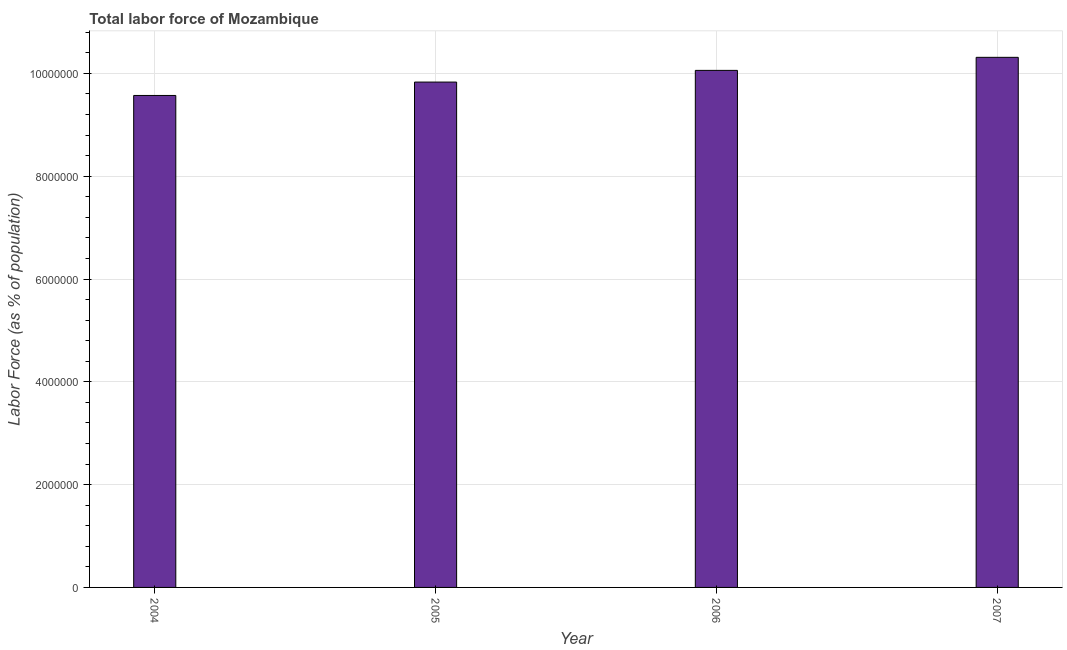What is the title of the graph?
Your answer should be very brief. Total labor force of Mozambique. What is the label or title of the X-axis?
Provide a short and direct response. Year. What is the label or title of the Y-axis?
Your answer should be compact. Labor Force (as % of population). What is the total labor force in 2005?
Ensure brevity in your answer.  9.83e+06. Across all years, what is the maximum total labor force?
Ensure brevity in your answer.  1.03e+07. Across all years, what is the minimum total labor force?
Your answer should be compact. 9.57e+06. In which year was the total labor force maximum?
Provide a succinct answer. 2007. In which year was the total labor force minimum?
Offer a very short reply. 2004. What is the sum of the total labor force?
Offer a very short reply. 3.98e+07. What is the difference between the total labor force in 2004 and 2007?
Provide a succinct answer. -7.42e+05. What is the average total labor force per year?
Keep it short and to the point. 9.94e+06. What is the median total labor force?
Give a very brief answer. 9.95e+06. In how many years, is the total labor force greater than 7600000 %?
Ensure brevity in your answer.  4. What is the difference between the highest and the second highest total labor force?
Provide a short and direct response. 2.54e+05. What is the difference between the highest and the lowest total labor force?
Provide a short and direct response. 7.42e+05. In how many years, is the total labor force greater than the average total labor force taken over all years?
Make the answer very short. 2. How many bars are there?
Provide a succinct answer. 4. Are all the bars in the graph horizontal?
Your answer should be very brief. No. What is the Labor Force (as % of population) of 2004?
Offer a very short reply. 9.57e+06. What is the Labor Force (as % of population) in 2005?
Keep it short and to the point. 9.83e+06. What is the Labor Force (as % of population) in 2006?
Give a very brief answer. 1.01e+07. What is the Labor Force (as % of population) of 2007?
Your answer should be compact. 1.03e+07. What is the difference between the Labor Force (as % of population) in 2004 and 2005?
Ensure brevity in your answer.  -2.61e+05. What is the difference between the Labor Force (as % of population) in 2004 and 2006?
Your response must be concise. -4.88e+05. What is the difference between the Labor Force (as % of population) in 2004 and 2007?
Keep it short and to the point. -7.42e+05. What is the difference between the Labor Force (as % of population) in 2005 and 2006?
Your answer should be very brief. -2.27e+05. What is the difference between the Labor Force (as % of population) in 2005 and 2007?
Keep it short and to the point. -4.81e+05. What is the difference between the Labor Force (as % of population) in 2006 and 2007?
Ensure brevity in your answer.  -2.54e+05. What is the ratio of the Labor Force (as % of population) in 2004 to that in 2006?
Make the answer very short. 0.95. What is the ratio of the Labor Force (as % of population) in 2004 to that in 2007?
Keep it short and to the point. 0.93. What is the ratio of the Labor Force (as % of population) in 2005 to that in 2007?
Offer a very short reply. 0.95. 